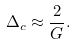Convert formula to latex. <formula><loc_0><loc_0><loc_500><loc_500>\Delta _ { c } \approx \frac { 2 } { G } .</formula> 